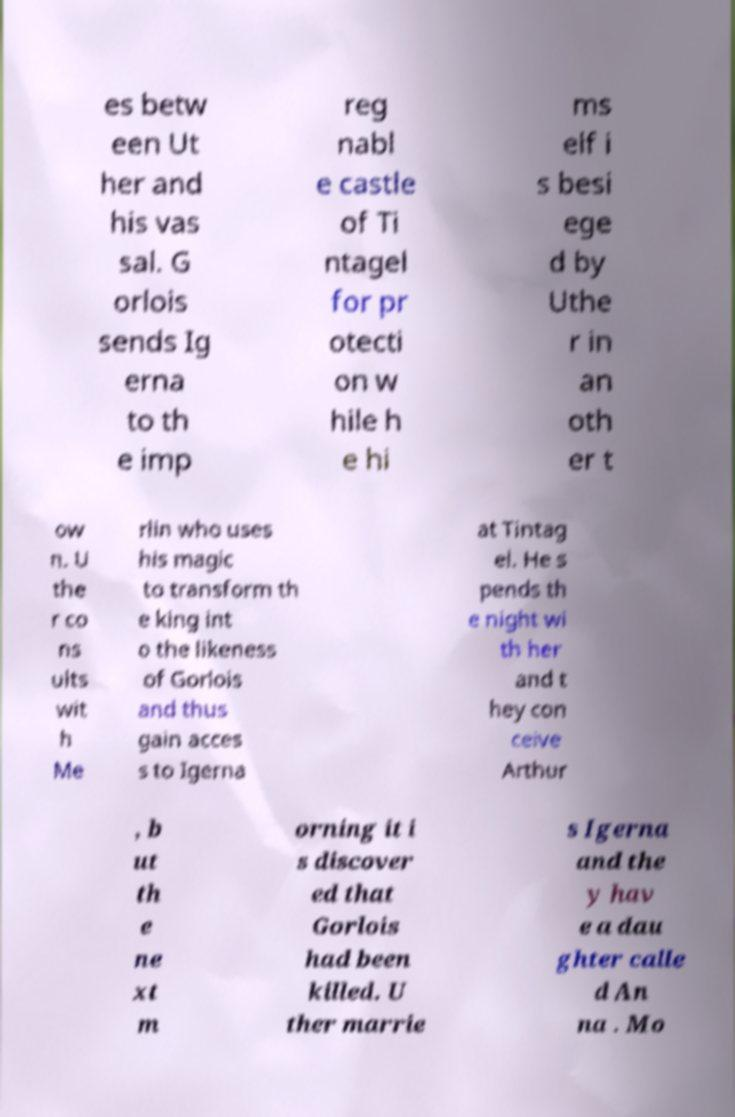What messages or text are displayed in this image? I need them in a readable, typed format. es betw een Ut her and his vas sal. G orlois sends Ig erna to th e imp reg nabl e castle of Ti ntagel for pr otecti on w hile h e hi ms elf i s besi ege d by Uthe r in an oth er t ow n. U the r co ns ults wit h Me rlin who uses his magic to transform th e king int o the likeness of Gorlois and thus gain acces s to Igerna at Tintag el. He s pends th e night wi th her and t hey con ceive Arthur , b ut th e ne xt m orning it i s discover ed that Gorlois had been killed. U ther marrie s Igerna and the y hav e a dau ghter calle d An na . Mo 